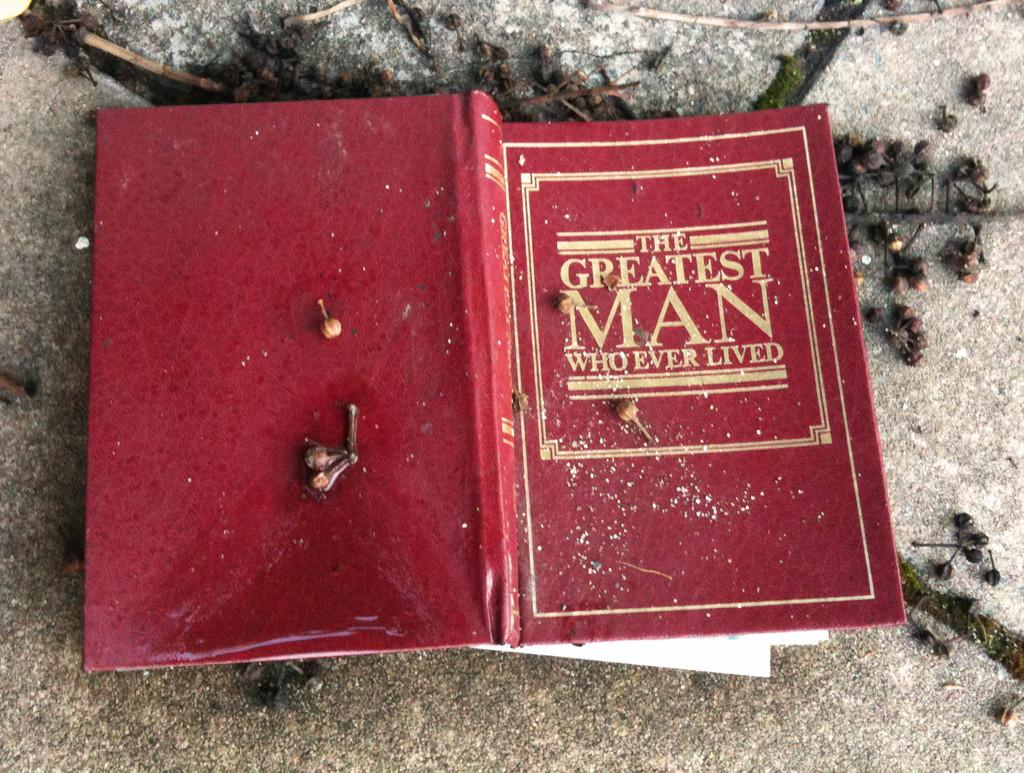What is the main object in the image? There is a book in the image. What color is the book? The book is red in color. What can be found on the book? There is text written on the book. Are there any other objects in the image that share a common characteristic? Yes, there are objects in the image that are black in color. How many dolls are featured in the advertisement in the image? There is no advertisement or dolls present in the image; it only features a red book with text and black objects. 